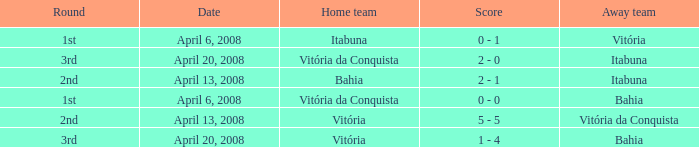On which date was the score 0 - 0? April 6, 2008. 